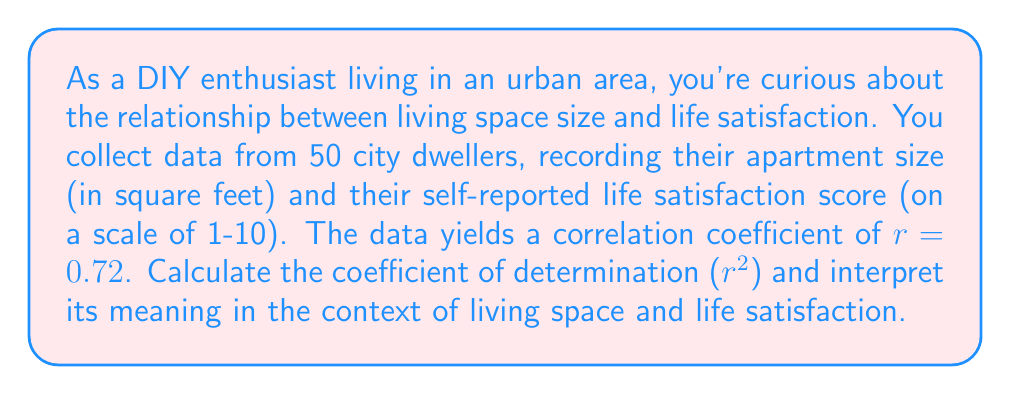Teach me how to tackle this problem. To solve this problem, we need to follow these steps:

1. Understand the meaning of the correlation coefficient $(r)$:
   The correlation coefficient measures the strength and direction of a linear relationship between two variables. It ranges from -1 to +1, where:
   - $r = 1$ indicates a perfect positive linear relationship
   - $r = -1$ indicates a perfect negative linear relationship
   - $r = 0$ indicates no linear relationship

2. Calculate the coefficient of determination $(r^2)$:
   The coefficient of determination is simply the square of the correlation coefficient.
   
   $r^2 = (0.72)^2 = 0.5184$

3. Interpret the meaning of $r^2$:
   The coefficient of determination represents the proportion of the variance in the dependent variable (life satisfaction) that is predictable from the independent variable (living space size).

   In this case, $r^2 = 0.5184$ or 51.84%

   This means that approximately 51.84% of the variability in life satisfaction scores can be explained by the linear relationship with living space size.

4. Contextualize the result:
   For a city dweller who loves DIY projects and appreciates personal space, this result suggests that there is a moderate to strong positive relationship between living space size and life satisfaction in urban areas. However, it's important to note that while living space size is a significant factor, it doesn't explain all the variation in life satisfaction (as it only accounts for about 52% of the variability).
Answer: The coefficient of determination $(r^2)$ is 0.5184 or 51.84%. This means that approximately 51.84% of the variability in life satisfaction scores can be explained by the linear relationship with living space size in urban areas. 